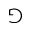<formula> <loc_0><loc_0><loc_500><loc_500>\ G a m e</formula> 